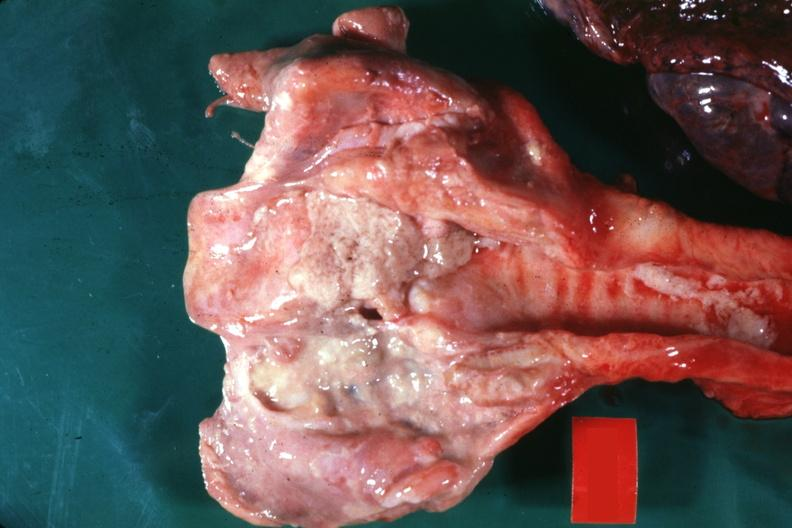s ulcer present?
Answer the question using a single word or phrase. Yes 